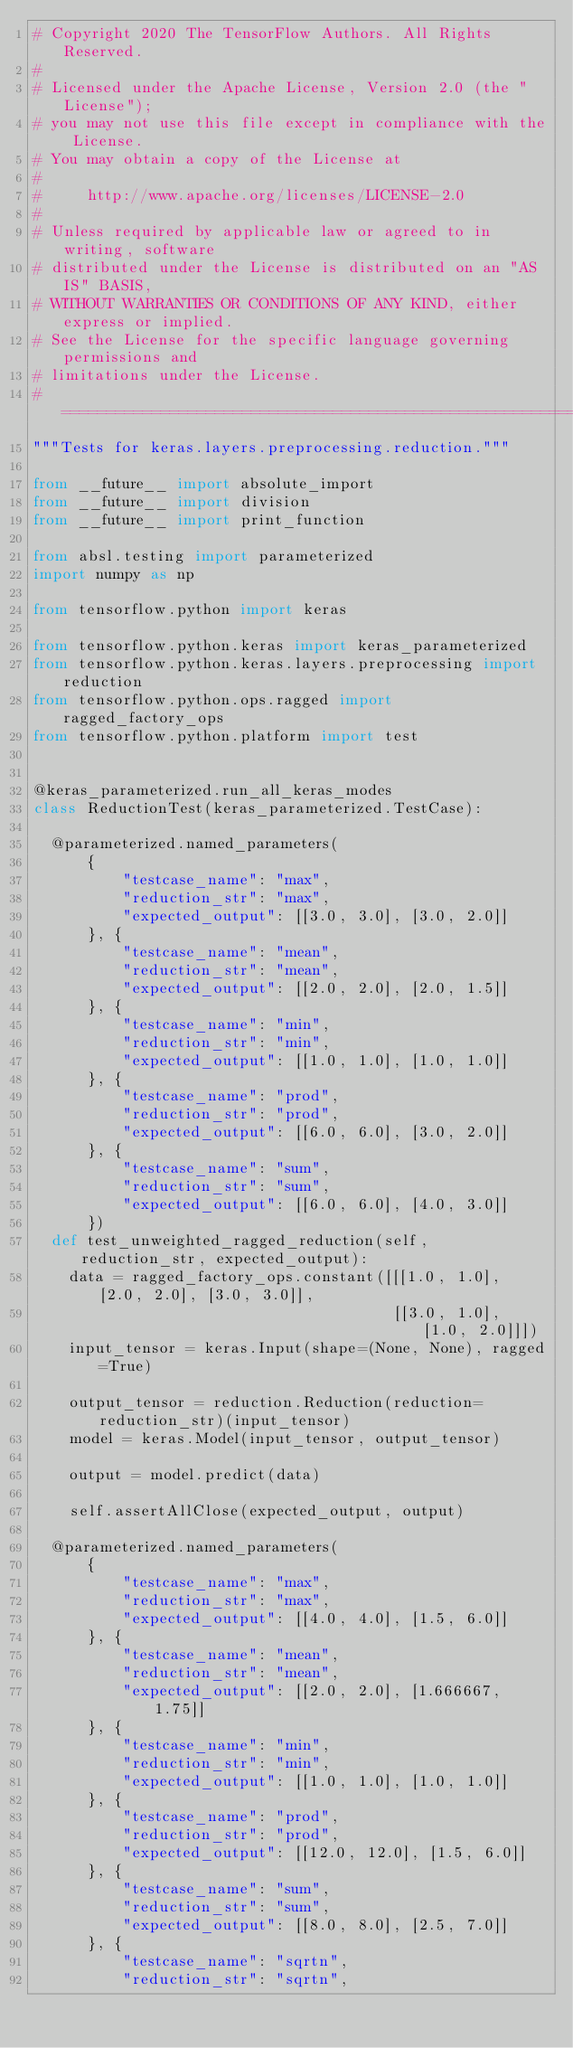<code> <loc_0><loc_0><loc_500><loc_500><_Python_># Copyright 2020 The TensorFlow Authors. All Rights Reserved.
#
# Licensed under the Apache License, Version 2.0 (the "License");
# you may not use this file except in compliance with the License.
# You may obtain a copy of the License at
#
#     http://www.apache.org/licenses/LICENSE-2.0
#
# Unless required by applicable law or agreed to in writing, software
# distributed under the License is distributed on an "AS IS" BASIS,
# WITHOUT WARRANTIES OR CONDITIONS OF ANY KIND, either express or implied.
# See the License for the specific language governing permissions and
# limitations under the License.
# ==============================================================================
"""Tests for keras.layers.preprocessing.reduction."""

from __future__ import absolute_import
from __future__ import division
from __future__ import print_function

from absl.testing import parameterized
import numpy as np

from tensorflow.python import keras

from tensorflow.python.keras import keras_parameterized
from tensorflow.python.keras.layers.preprocessing import reduction
from tensorflow.python.ops.ragged import ragged_factory_ops
from tensorflow.python.platform import test


@keras_parameterized.run_all_keras_modes
class ReductionTest(keras_parameterized.TestCase):

  @parameterized.named_parameters(
      {
          "testcase_name": "max",
          "reduction_str": "max",
          "expected_output": [[3.0, 3.0], [3.0, 2.0]]
      }, {
          "testcase_name": "mean",
          "reduction_str": "mean",
          "expected_output": [[2.0, 2.0], [2.0, 1.5]]
      }, {
          "testcase_name": "min",
          "reduction_str": "min",
          "expected_output": [[1.0, 1.0], [1.0, 1.0]]
      }, {
          "testcase_name": "prod",
          "reduction_str": "prod",
          "expected_output": [[6.0, 6.0], [3.0, 2.0]]
      }, {
          "testcase_name": "sum",
          "reduction_str": "sum",
          "expected_output": [[6.0, 6.0], [4.0, 3.0]]
      })
  def test_unweighted_ragged_reduction(self, reduction_str, expected_output):
    data = ragged_factory_ops.constant([[[1.0, 1.0], [2.0, 2.0], [3.0, 3.0]],
                                        [[3.0, 1.0], [1.0, 2.0]]])
    input_tensor = keras.Input(shape=(None, None), ragged=True)

    output_tensor = reduction.Reduction(reduction=reduction_str)(input_tensor)
    model = keras.Model(input_tensor, output_tensor)

    output = model.predict(data)

    self.assertAllClose(expected_output, output)

  @parameterized.named_parameters(
      {
          "testcase_name": "max",
          "reduction_str": "max",
          "expected_output": [[4.0, 4.0], [1.5, 6.0]]
      }, {
          "testcase_name": "mean",
          "reduction_str": "mean",
          "expected_output": [[2.0, 2.0], [1.666667, 1.75]]
      }, {
          "testcase_name": "min",
          "reduction_str": "min",
          "expected_output": [[1.0, 1.0], [1.0, 1.0]]
      }, {
          "testcase_name": "prod",
          "reduction_str": "prod",
          "expected_output": [[12.0, 12.0], [1.5, 6.0]]
      }, {
          "testcase_name": "sum",
          "reduction_str": "sum",
          "expected_output": [[8.0, 8.0], [2.5, 7.0]]
      }, {
          "testcase_name": "sqrtn",
          "reduction_str": "sqrtn",</code> 